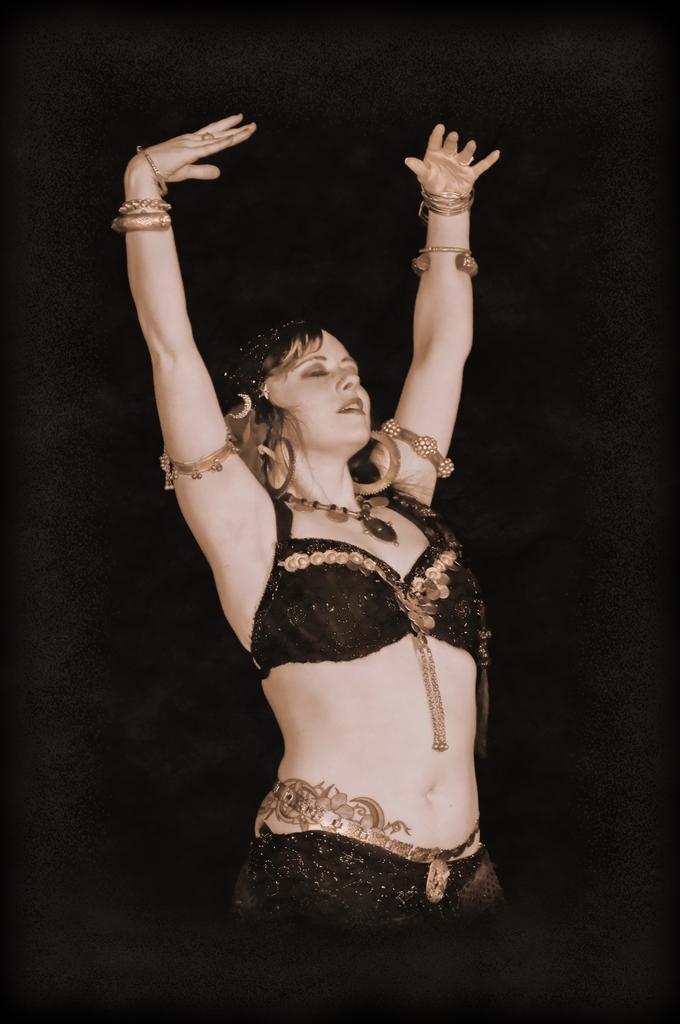What is happening in the image? There is a person in the image, and they are dancing. What can be observed about the background of the image? The background of the image is dark. What type of leather is being used to make the soup in the image? There is no soup or leather present in the image; it features a person dancing against a dark background. 